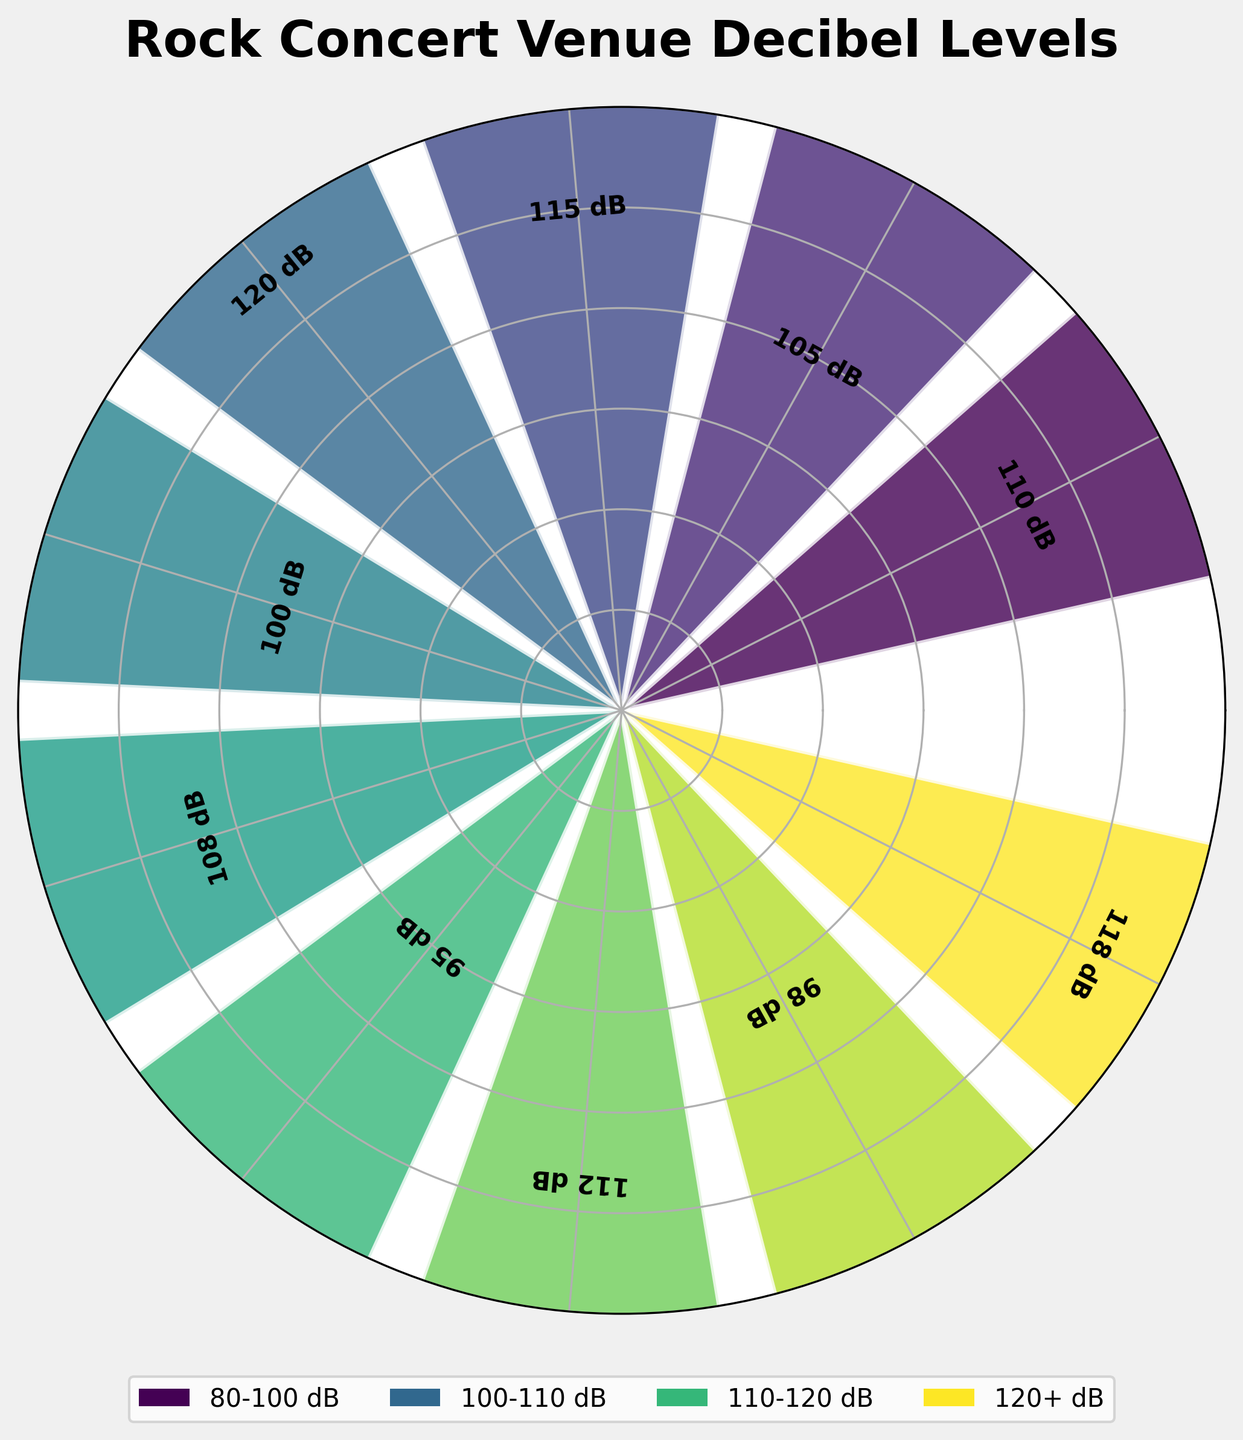what is the decibel level of Madison Square Garden? The label above Madison Square Garden indicates the decibel level directly.
Answer: 110 dB Which venue has the highest decibel level? By comparing the labels, Wembley Stadium has the highest level at 120 dB.
Answer: Wembley Stadium What's the range of decibel levels displayed? The lowest level is 95 dB (Royal Albert Hall) and the highest is 120 dB (Wembley Stadium), so the range is 120 dB - 95 dB = 25 dB.
Answer: 25 dB Which venues have decibel levels greater than 110 dB? Checking the labels, the venues are Red Rocks Amphitheatre (115 dB), Fillmore East (112 dB), O2 Arena (118 dB), and Wembley Stadium (120 dB).
Answer: Red Rocks Amphitheatre, Fillmore East, O2 Arena, Wembley Stadium How many venues have decibel levels less than 100 dB? Royal Albert Hall (95 dB) and The Cavern Club (98 dB) are both below 100 dB.
Answer: 2 What is the average decibel level of all the venues? Sum all the levels [110, 105, 115, 120, 100, 108, 95, 112, 98, 118] = 1081. Divide by the number of venues, 1081/10 = 108.1.
Answer: 108.1 dB Which venue has the closest decibel level to the average? The average is 108.1 dB; comparing, Whisky a Go Go has 108 dB, which is closest.
Answer: Whisky a Go Go What is the difference in decibel levels between The Roxy Theatre and CBGB? The level for The Roxy Theatre is 105 dB and for CBGB is 100 dB; the difference is 105 dB - 100 dB = 5 dB.
Answer: 5 dB What's the decibel level range for the middle 50% of venues? Sorting the levels: [95, 98, 100, 105, 108, 110, 112, 115, 118, 120]; the middle four are [105, 108, 110, 112]; so the range is 112 - 105 = 7 dB.
Answer: 7 dB Which venues are in the '110-120 dB' category according to the legend? According to the figure's color legend, it includes Madison Square Garden (110 dB), Red Rocks Amphitheatre (115 dB), Fillmore East (112 dB), O2 Arena (118 dB), and Wembley Stadium (120 dB).
Answer: Madison Square Garden, Red Rocks Amphitheatre, Fillmore East, O2 Arena, Wembley Stadium 